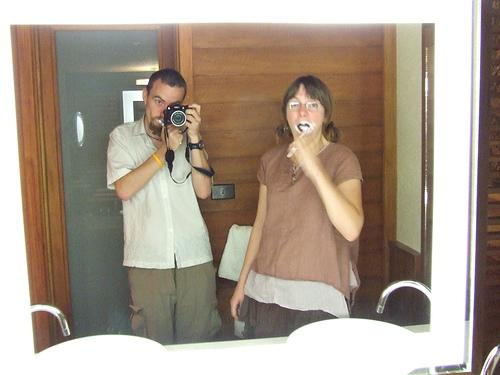Question: where was this photo taken?
Choices:
A. Bedroom.
B. Kitchen.
C. Outdoors.
D. In a bathroom.
Answer with the letter. Answer: D Question: what is the woman doing in photo?
Choices:
A. Brushing her teeth.
B. Brushing her hair.
C. Running.
D. Swimming.
Answer with the letter. Answer: A Question: when was this photo taken?
Choices:
A. Morning.
B. Afternoon.
C. In the daytime.
D. Night.
Answer with the letter. Answer: C Question: who is holding the camera?
Choices:
A. Woman.
B. Child.
C. The man.
D. Photographer.
Answer with the letter. Answer: C 